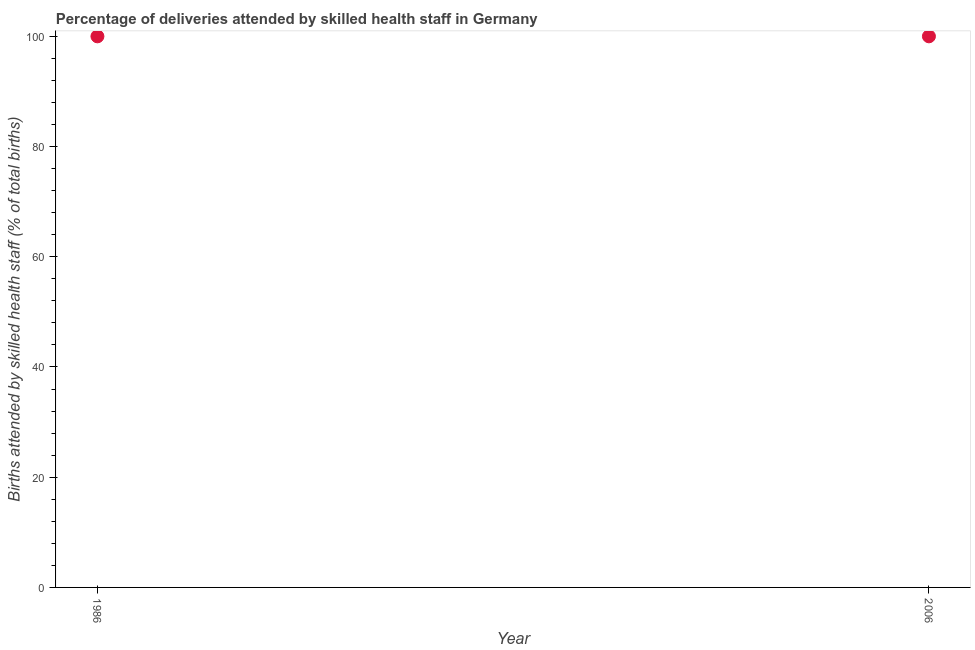What is the number of births attended by skilled health staff in 2006?
Provide a short and direct response. 100. Across all years, what is the maximum number of births attended by skilled health staff?
Provide a succinct answer. 100. Across all years, what is the minimum number of births attended by skilled health staff?
Keep it short and to the point. 100. In which year was the number of births attended by skilled health staff maximum?
Make the answer very short. 1986. In which year was the number of births attended by skilled health staff minimum?
Offer a terse response. 1986. What is the sum of the number of births attended by skilled health staff?
Give a very brief answer. 200. What is the average number of births attended by skilled health staff per year?
Give a very brief answer. 100. In how many years, is the number of births attended by skilled health staff greater than 84 %?
Provide a succinct answer. 2. Do a majority of the years between 1986 and 2006 (inclusive) have number of births attended by skilled health staff greater than 48 %?
Make the answer very short. Yes. In how many years, is the number of births attended by skilled health staff greater than the average number of births attended by skilled health staff taken over all years?
Provide a short and direct response. 0. How many dotlines are there?
Offer a very short reply. 1. How many years are there in the graph?
Give a very brief answer. 2. Are the values on the major ticks of Y-axis written in scientific E-notation?
Provide a short and direct response. No. What is the title of the graph?
Provide a succinct answer. Percentage of deliveries attended by skilled health staff in Germany. What is the label or title of the X-axis?
Your answer should be very brief. Year. What is the label or title of the Y-axis?
Provide a succinct answer. Births attended by skilled health staff (% of total births). What is the Births attended by skilled health staff (% of total births) in 2006?
Your answer should be compact. 100. 